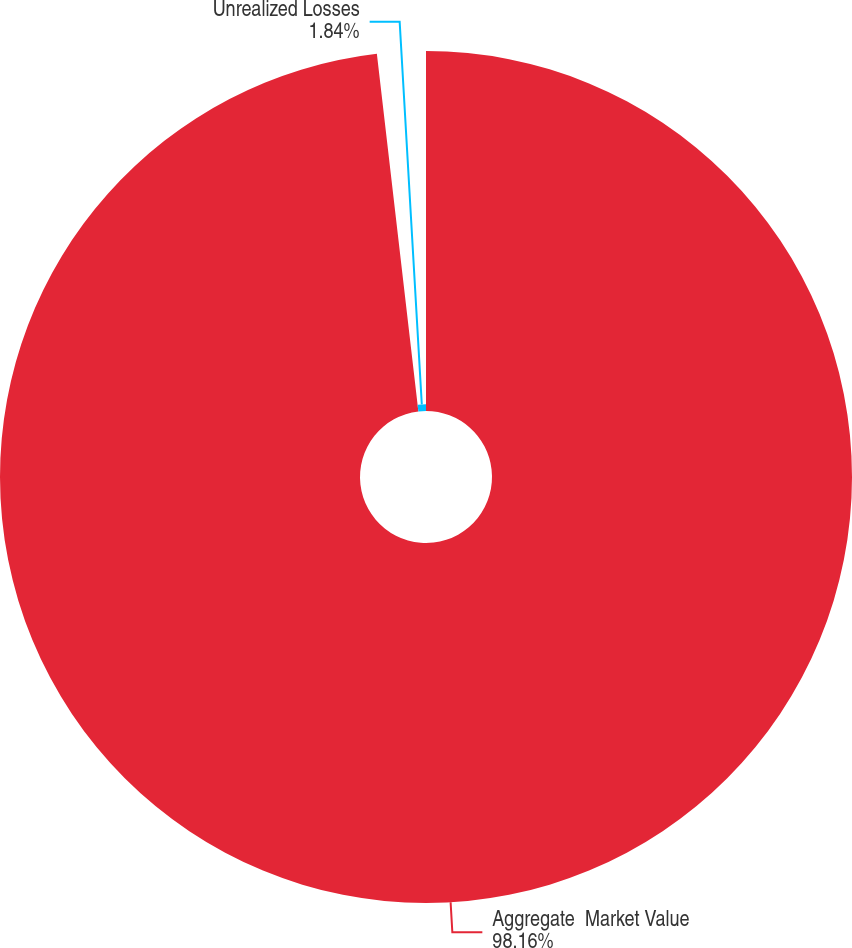<chart> <loc_0><loc_0><loc_500><loc_500><pie_chart><fcel>Aggregate  Market Value<fcel>Unrealized Losses<nl><fcel>98.16%<fcel>1.84%<nl></chart> 